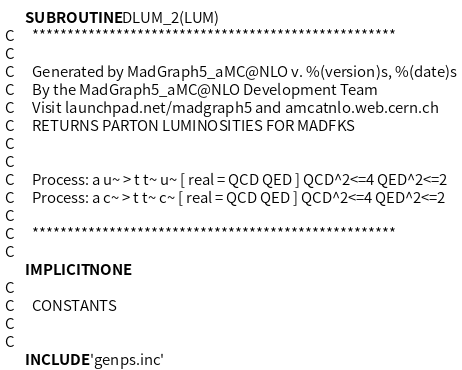<code> <loc_0><loc_0><loc_500><loc_500><_FORTRAN_>      SUBROUTINE DLUM_2(LUM)
C     ****************************************************            
C         
C     Generated by MadGraph5_aMC@NLO v. %(version)s, %(date)s
C     By the MadGraph5_aMC@NLO Development Team
C     Visit launchpad.net/madgraph5 and amcatnlo.web.cern.ch
C     RETURNS PARTON LUMINOSITIES FOR MADFKS                          
C        
C     
C     Process: a u~ > t t~ u~ [ real = QCD QED ] QCD^2<=4 QED^2<=2
C     Process: a c~ > t t~ c~ [ real = QCD QED ] QCD^2<=4 QED^2<=2
C     
C     ****************************************************            
C         
      IMPLICIT NONE
C     
C     CONSTANTS                                                       
C         
C     
      INCLUDE 'genps.inc'</code> 